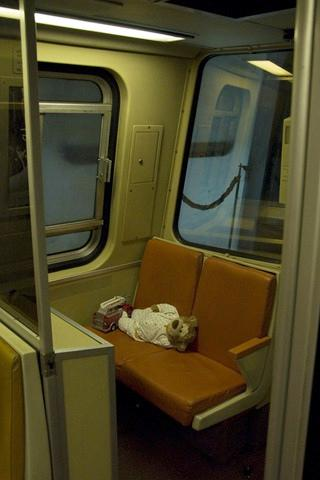Question: what kind of toy vehicle is shown?
Choices:
A. Racecar.
B. Dumptruck.
C. Firetruck.
D. Motorcycle.
Answer with the letter. Answer: C Question: how many toys are on the bench?
Choices:
A. Two.
B. One.
C. Five.
D. Three.
Answer with the letter. Answer: A 